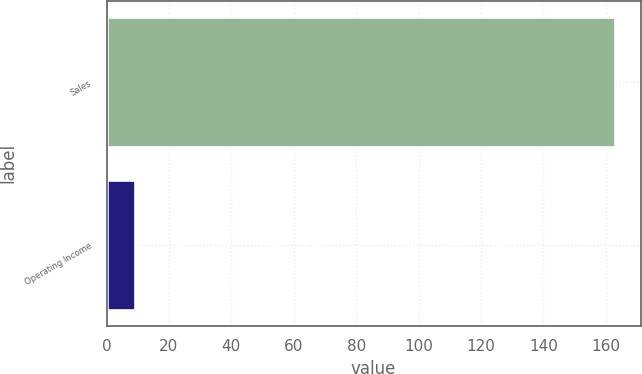<chart> <loc_0><loc_0><loc_500><loc_500><bar_chart><fcel>Sales<fcel>Operating Income<nl><fcel>163<fcel>9<nl></chart> 